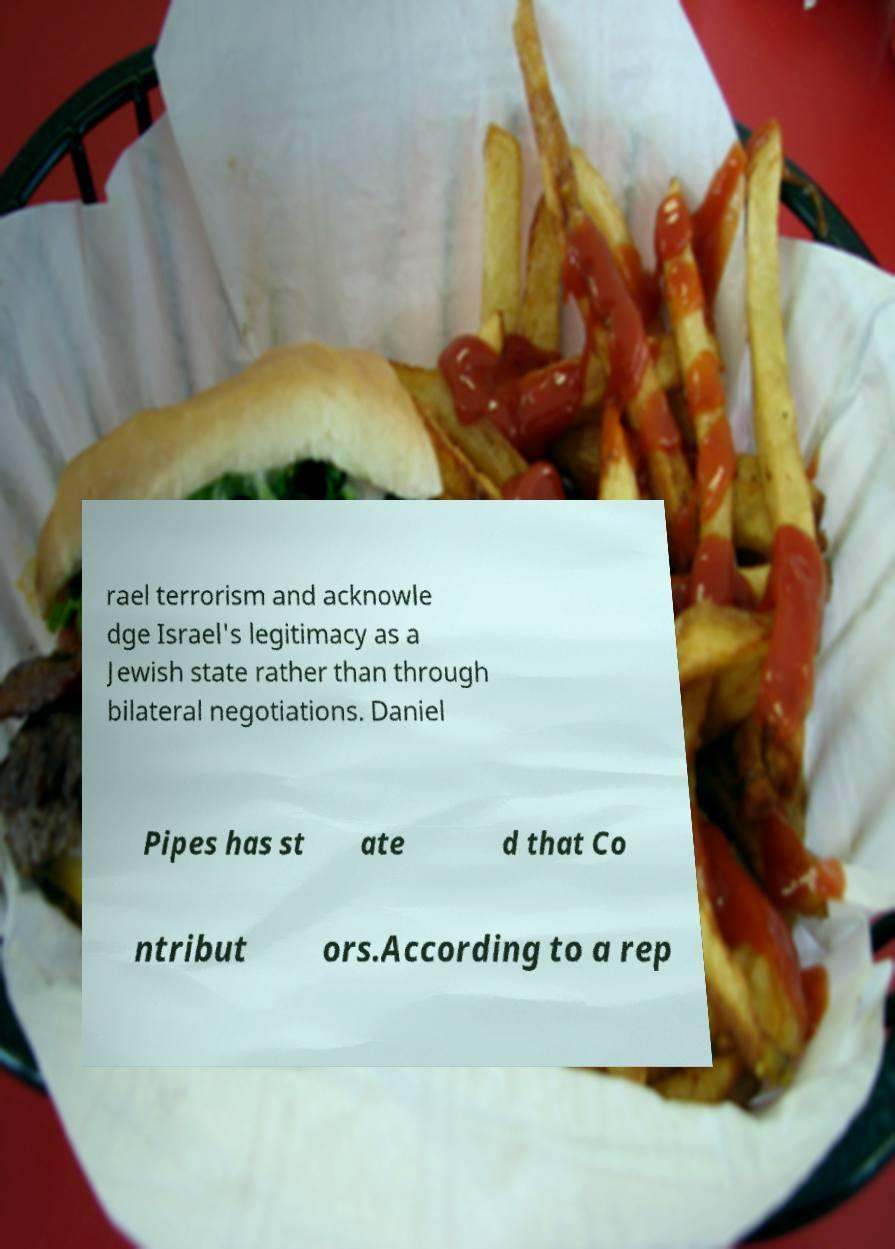Could you assist in decoding the text presented in this image and type it out clearly? rael terrorism and acknowle dge Israel's legitimacy as a Jewish state rather than through bilateral negotiations. Daniel Pipes has st ate d that Co ntribut ors.According to a rep 